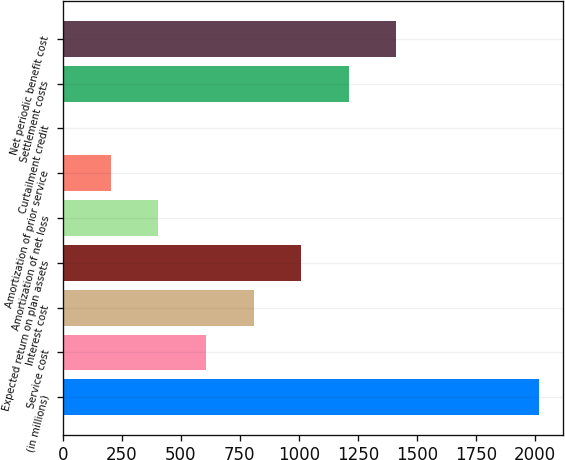<chart> <loc_0><loc_0><loc_500><loc_500><bar_chart><fcel>(in millions)<fcel>Service cost<fcel>Interest cost<fcel>Expected return on plan assets<fcel>Amortization of net loss<fcel>Amortization of prior service<fcel>Curtailment credit<fcel>Settlement costs<fcel>Net periodic benefit cost<nl><fcel>2017<fcel>606.36<fcel>807.88<fcel>1009.4<fcel>404.84<fcel>203.32<fcel>1.8<fcel>1210.92<fcel>1412.44<nl></chart> 